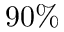Convert formula to latex. <formula><loc_0><loc_0><loc_500><loc_500>9 0 \%</formula> 